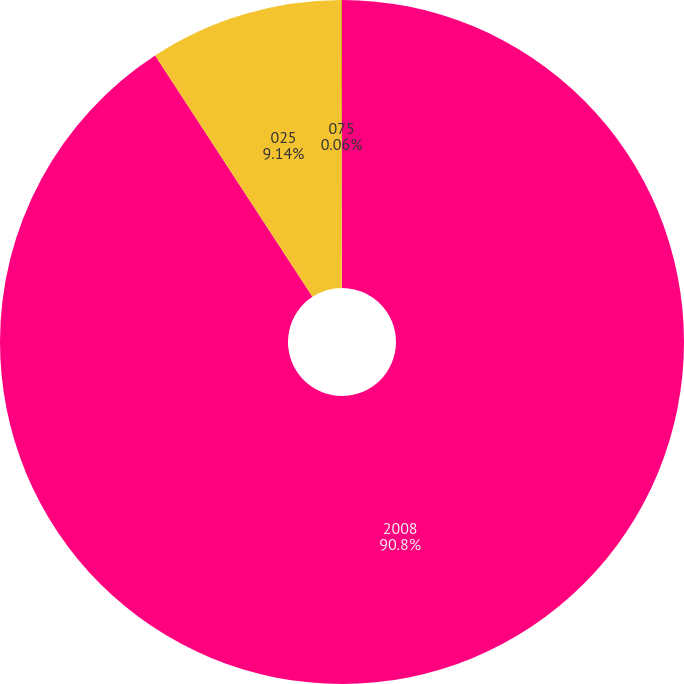Convert chart. <chart><loc_0><loc_0><loc_500><loc_500><pie_chart><fcel>2008<fcel>025<fcel>075<nl><fcel>90.8%<fcel>9.14%<fcel>0.06%<nl></chart> 